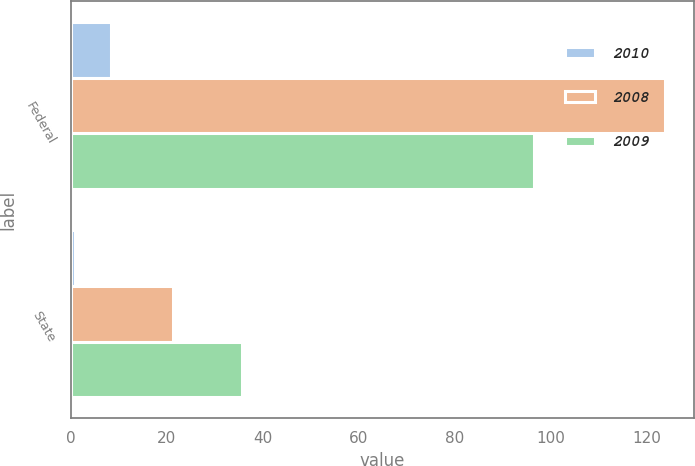Convert chart to OTSL. <chart><loc_0><loc_0><loc_500><loc_500><stacked_bar_chart><ecel><fcel>Federal<fcel>State<nl><fcel>2010<fcel>8.4<fcel>1<nl><fcel>2008<fcel>123.8<fcel>21.4<nl><fcel>2009<fcel>96.6<fcel>35.8<nl></chart> 